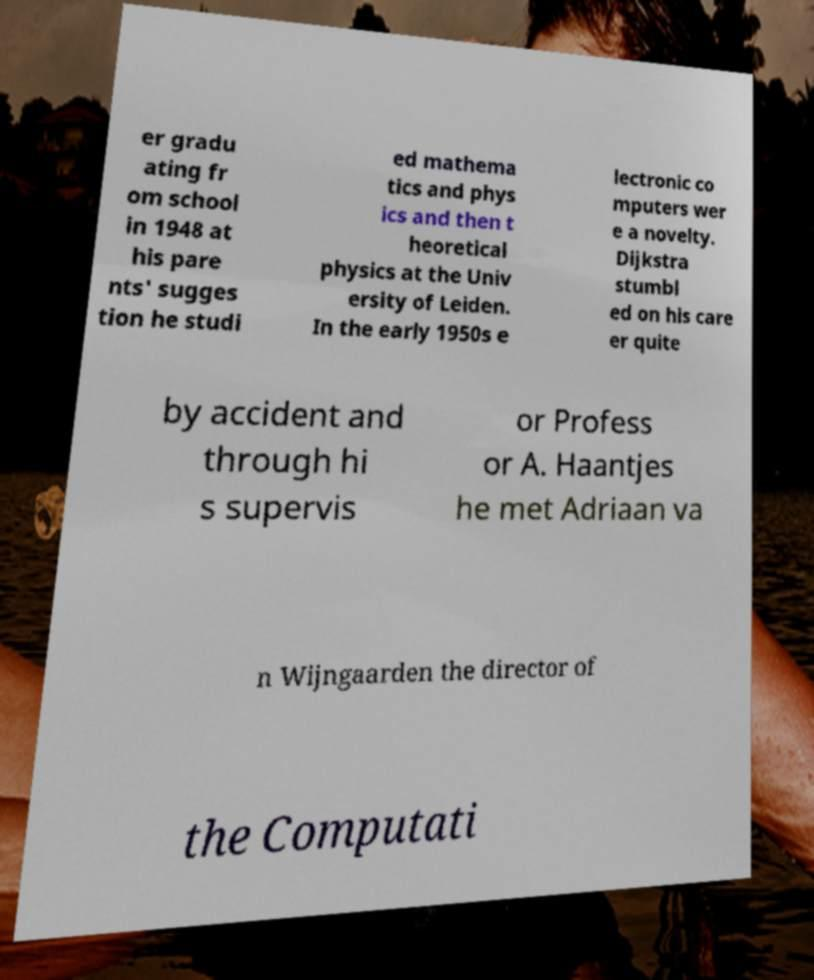Can you read and provide the text displayed in the image?This photo seems to have some interesting text. Can you extract and type it out for me? er gradu ating fr om school in 1948 at his pare nts' sugges tion he studi ed mathema tics and phys ics and then t heoretical physics at the Univ ersity of Leiden. In the early 1950s e lectronic co mputers wer e a novelty. Dijkstra stumbl ed on his care er quite by accident and through hi s supervis or Profess or A. Haantjes he met Adriaan va n Wijngaarden the director of the Computati 